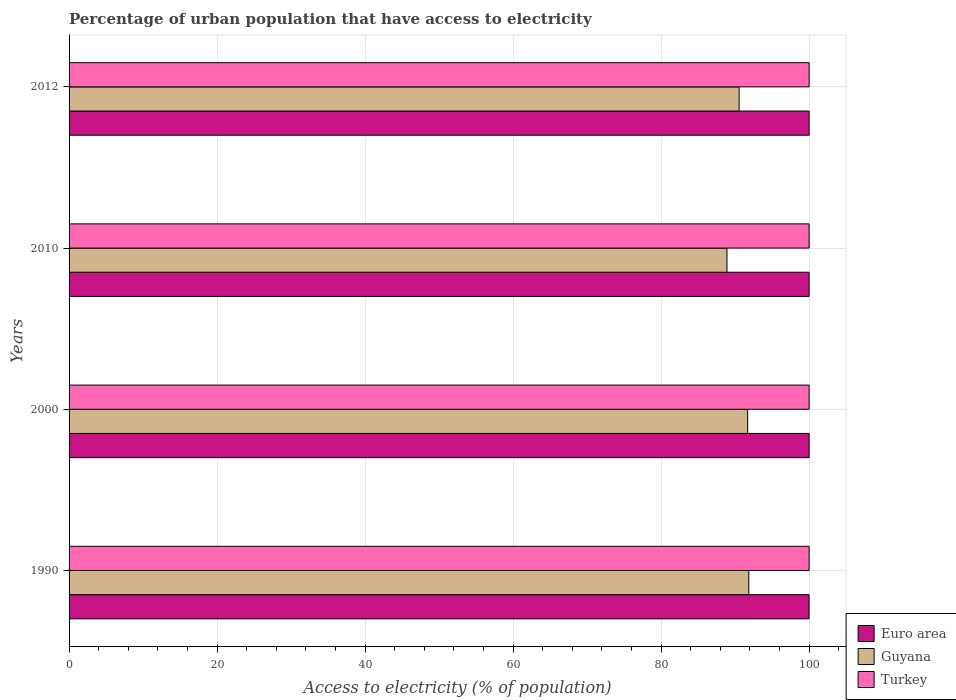How many different coloured bars are there?
Keep it short and to the point. 3. How many groups of bars are there?
Provide a short and direct response. 4. What is the percentage of urban population that have access to electricity in Euro area in 1990?
Ensure brevity in your answer.  99.99. Across all years, what is the maximum percentage of urban population that have access to electricity in Turkey?
Offer a terse response. 100. Across all years, what is the minimum percentage of urban population that have access to electricity in Euro area?
Your answer should be compact. 99.99. In which year was the percentage of urban population that have access to electricity in Turkey maximum?
Provide a succinct answer. 1990. What is the total percentage of urban population that have access to electricity in Guyana in the graph?
Give a very brief answer. 362.99. What is the difference between the percentage of urban population that have access to electricity in Turkey in 2010 and that in 2012?
Ensure brevity in your answer.  0. What is the difference between the percentage of urban population that have access to electricity in Guyana in 1990 and the percentage of urban population that have access to electricity in Euro area in 2012?
Make the answer very short. -8.15. What is the average percentage of urban population that have access to electricity in Turkey per year?
Your answer should be very brief. 100. In the year 1990, what is the difference between the percentage of urban population that have access to electricity in Guyana and percentage of urban population that have access to electricity in Turkey?
Offer a terse response. -8.15. What is the ratio of the percentage of urban population that have access to electricity in Turkey in 2000 to that in 2012?
Your answer should be very brief. 1. Is the percentage of urban population that have access to electricity in Guyana in 1990 less than that in 2010?
Your answer should be compact. No. Is the difference between the percentage of urban population that have access to electricity in Guyana in 1990 and 2010 greater than the difference between the percentage of urban population that have access to electricity in Turkey in 1990 and 2010?
Provide a short and direct response. Yes. What is the difference between the highest and the second highest percentage of urban population that have access to electricity in Guyana?
Your answer should be very brief. 0.16. What is the difference between the highest and the lowest percentage of urban population that have access to electricity in Guyana?
Keep it short and to the point. 2.95. What does the 2nd bar from the bottom in 2010 represents?
Ensure brevity in your answer.  Guyana. Are all the bars in the graph horizontal?
Offer a very short reply. Yes. How many years are there in the graph?
Keep it short and to the point. 4. Are the values on the major ticks of X-axis written in scientific E-notation?
Offer a terse response. No. Does the graph contain any zero values?
Provide a succinct answer. No. Does the graph contain grids?
Provide a succinct answer. Yes. Where does the legend appear in the graph?
Provide a succinct answer. Bottom right. How many legend labels are there?
Make the answer very short. 3. How are the legend labels stacked?
Make the answer very short. Vertical. What is the title of the graph?
Ensure brevity in your answer.  Percentage of urban population that have access to electricity. What is the label or title of the X-axis?
Provide a short and direct response. Access to electricity (% of population). What is the label or title of the Y-axis?
Give a very brief answer. Years. What is the Access to electricity (% of population) in Euro area in 1990?
Make the answer very short. 99.99. What is the Access to electricity (% of population) in Guyana in 1990?
Keep it short and to the point. 91.85. What is the Access to electricity (% of population) in Euro area in 2000?
Offer a very short reply. 100. What is the Access to electricity (% of population) of Guyana in 2000?
Offer a very short reply. 91.69. What is the Access to electricity (% of population) in Euro area in 2010?
Your response must be concise. 100. What is the Access to electricity (% of population) in Guyana in 2010?
Ensure brevity in your answer.  88.9. What is the Access to electricity (% of population) of Euro area in 2012?
Your answer should be very brief. 100. What is the Access to electricity (% of population) in Guyana in 2012?
Make the answer very short. 90.54. What is the Access to electricity (% of population) of Turkey in 2012?
Provide a succinct answer. 100. Across all years, what is the maximum Access to electricity (% of population) in Guyana?
Your answer should be very brief. 91.85. Across all years, what is the minimum Access to electricity (% of population) of Euro area?
Make the answer very short. 99.99. Across all years, what is the minimum Access to electricity (% of population) of Guyana?
Offer a very short reply. 88.9. What is the total Access to electricity (% of population) of Euro area in the graph?
Provide a short and direct response. 399.99. What is the total Access to electricity (% of population) of Guyana in the graph?
Your answer should be compact. 362.99. What is the difference between the Access to electricity (% of population) in Euro area in 1990 and that in 2000?
Offer a very short reply. -0.01. What is the difference between the Access to electricity (% of population) in Guyana in 1990 and that in 2000?
Ensure brevity in your answer.  0.16. What is the difference between the Access to electricity (% of population) in Euro area in 1990 and that in 2010?
Keep it short and to the point. -0.01. What is the difference between the Access to electricity (% of population) of Guyana in 1990 and that in 2010?
Provide a short and direct response. 2.95. What is the difference between the Access to electricity (% of population) of Euro area in 1990 and that in 2012?
Keep it short and to the point. -0.01. What is the difference between the Access to electricity (% of population) in Guyana in 1990 and that in 2012?
Provide a succinct answer. 1.31. What is the difference between the Access to electricity (% of population) of Guyana in 2000 and that in 2010?
Keep it short and to the point. 2.79. What is the difference between the Access to electricity (% of population) in Turkey in 2000 and that in 2010?
Make the answer very short. 0. What is the difference between the Access to electricity (% of population) of Euro area in 2000 and that in 2012?
Your answer should be very brief. 0. What is the difference between the Access to electricity (% of population) in Guyana in 2000 and that in 2012?
Keep it short and to the point. 1.15. What is the difference between the Access to electricity (% of population) in Guyana in 2010 and that in 2012?
Ensure brevity in your answer.  -1.64. What is the difference between the Access to electricity (% of population) of Euro area in 1990 and the Access to electricity (% of population) of Guyana in 2000?
Provide a succinct answer. 8.3. What is the difference between the Access to electricity (% of population) in Euro area in 1990 and the Access to electricity (% of population) in Turkey in 2000?
Ensure brevity in your answer.  -0.01. What is the difference between the Access to electricity (% of population) in Guyana in 1990 and the Access to electricity (% of population) in Turkey in 2000?
Offer a very short reply. -8.15. What is the difference between the Access to electricity (% of population) of Euro area in 1990 and the Access to electricity (% of population) of Guyana in 2010?
Your answer should be compact. 11.09. What is the difference between the Access to electricity (% of population) of Euro area in 1990 and the Access to electricity (% of population) of Turkey in 2010?
Keep it short and to the point. -0.01. What is the difference between the Access to electricity (% of population) of Guyana in 1990 and the Access to electricity (% of population) of Turkey in 2010?
Your answer should be very brief. -8.15. What is the difference between the Access to electricity (% of population) of Euro area in 1990 and the Access to electricity (% of population) of Guyana in 2012?
Your response must be concise. 9.45. What is the difference between the Access to electricity (% of population) in Euro area in 1990 and the Access to electricity (% of population) in Turkey in 2012?
Give a very brief answer. -0.01. What is the difference between the Access to electricity (% of population) in Guyana in 1990 and the Access to electricity (% of population) in Turkey in 2012?
Make the answer very short. -8.15. What is the difference between the Access to electricity (% of population) of Euro area in 2000 and the Access to electricity (% of population) of Guyana in 2010?
Your response must be concise. 11.1. What is the difference between the Access to electricity (% of population) in Euro area in 2000 and the Access to electricity (% of population) in Turkey in 2010?
Make the answer very short. 0. What is the difference between the Access to electricity (% of population) in Guyana in 2000 and the Access to electricity (% of population) in Turkey in 2010?
Your answer should be compact. -8.31. What is the difference between the Access to electricity (% of population) of Euro area in 2000 and the Access to electricity (% of population) of Guyana in 2012?
Keep it short and to the point. 9.46. What is the difference between the Access to electricity (% of population) in Euro area in 2000 and the Access to electricity (% of population) in Turkey in 2012?
Make the answer very short. 0. What is the difference between the Access to electricity (% of population) of Guyana in 2000 and the Access to electricity (% of population) of Turkey in 2012?
Give a very brief answer. -8.31. What is the difference between the Access to electricity (% of population) in Euro area in 2010 and the Access to electricity (% of population) in Guyana in 2012?
Ensure brevity in your answer.  9.46. What is the difference between the Access to electricity (% of population) in Euro area in 2010 and the Access to electricity (% of population) in Turkey in 2012?
Your answer should be compact. 0. What is the difference between the Access to electricity (% of population) in Guyana in 2010 and the Access to electricity (% of population) in Turkey in 2012?
Provide a short and direct response. -11.1. What is the average Access to electricity (% of population) in Euro area per year?
Your response must be concise. 100. What is the average Access to electricity (% of population) in Guyana per year?
Provide a succinct answer. 90.75. What is the average Access to electricity (% of population) in Turkey per year?
Give a very brief answer. 100. In the year 1990, what is the difference between the Access to electricity (% of population) in Euro area and Access to electricity (% of population) in Guyana?
Offer a terse response. 8.14. In the year 1990, what is the difference between the Access to electricity (% of population) of Euro area and Access to electricity (% of population) of Turkey?
Ensure brevity in your answer.  -0.01. In the year 1990, what is the difference between the Access to electricity (% of population) in Guyana and Access to electricity (% of population) in Turkey?
Ensure brevity in your answer.  -8.15. In the year 2000, what is the difference between the Access to electricity (% of population) of Euro area and Access to electricity (% of population) of Guyana?
Give a very brief answer. 8.31. In the year 2000, what is the difference between the Access to electricity (% of population) in Euro area and Access to electricity (% of population) in Turkey?
Give a very brief answer. 0. In the year 2000, what is the difference between the Access to electricity (% of population) of Guyana and Access to electricity (% of population) of Turkey?
Offer a terse response. -8.31. In the year 2010, what is the difference between the Access to electricity (% of population) of Euro area and Access to electricity (% of population) of Guyana?
Provide a succinct answer. 11.1. In the year 2010, what is the difference between the Access to electricity (% of population) in Euro area and Access to electricity (% of population) in Turkey?
Provide a short and direct response. 0. In the year 2010, what is the difference between the Access to electricity (% of population) of Guyana and Access to electricity (% of population) of Turkey?
Keep it short and to the point. -11.1. In the year 2012, what is the difference between the Access to electricity (% of population) in Euro area and Access to electricity (% of population) in Guyana?
Your answer should be very brief. 9.46. In the year 2012, what is the difference between the Access to electricity (% of population) in Euro area and Access to electricity (% of population) in Turkey?
Give a very brief answer. 0. In the year 2012, what is the difference between the Access to electricity (% of population) of Guyana and Access to electricity (% of population) of Turkey?
Offer a terse response. -9.46. What is the ratio of the Access to electricity (% of population) in Guyana in 1990 to that in 2000?
Provide a succinct answer. 1. What is the ratio of the Access to electricity (% of population) of Guyana in 1990 to that in 2010?
Give a very brief answer. 1.03. What is the ratio of the Access to electricity (% of population) of Turkey in 1990 to that in 2010?
Your answer should be compact. 1. What is the ratio of the Access to electricity (% of population) of Euro area in 1990 to that in 2012?
Keep it short and to the point. 1. What is the ratio of the Access to electricity (% of population) in Guyana in 1990 to that in 2012?
Give a very brief answer. 1.01. What is the ratio of the Access to electricity (% of population) of Turkey in 1990 to that in 2012?
Give a very brief answer. 1. What is the ratio of the Access to electricity (% of population) in Guyana in 2000 to that in 2010?
Ensure brevity in your answer.  1.03. What is the ratio of the Access to electricity (% of population) in Turkey in 2000 to that in 2010?
Provide a short and direct response. 1. What is the ratio of the Access to electricity (% of population) in Guyana in 2000 to that in 2012?
Keep it short and to the point. 1.01. What is the ratio of the Access to electricity (% of population) of Turkey in 2000 to that in 2012?
Your response must be concise. 1. What is the ratio of the Access to electricity (% of population) in Euro area in 2010 to that in 2012?
Your answer should be compact. 1. What is the ratio of the Access to electricity (% of population) in Guyana in 2010 to that in 2012?
Offer a very short reply. 0.98. What is the ratio of the Access to electricity (% of population) in Turkey in 2010 to that in 2012?
Your answer should be very brief. 1. What is the difference between the highest and the second highest Access to electricity (% of population) of Guyana?
Provide a short and direct response. 0.16. What is the difference between the highest and the second highest Access to electricity (% of population) of Turkey?
Offer a terse response. 0. What is the difference between the highest and the lowest Access to electricity (% of population) in Euro area?
Give a very brief answer. 0.01. What is the difference between the highest and the lowest Access to electricity (% of population) in Guyana?
Keep it short and to the point. 2.95. 